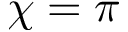Convert formula to latex. <formula><loc_0><loc_0><loc_500><loc_500>{ \chi = \pi }</formula> 